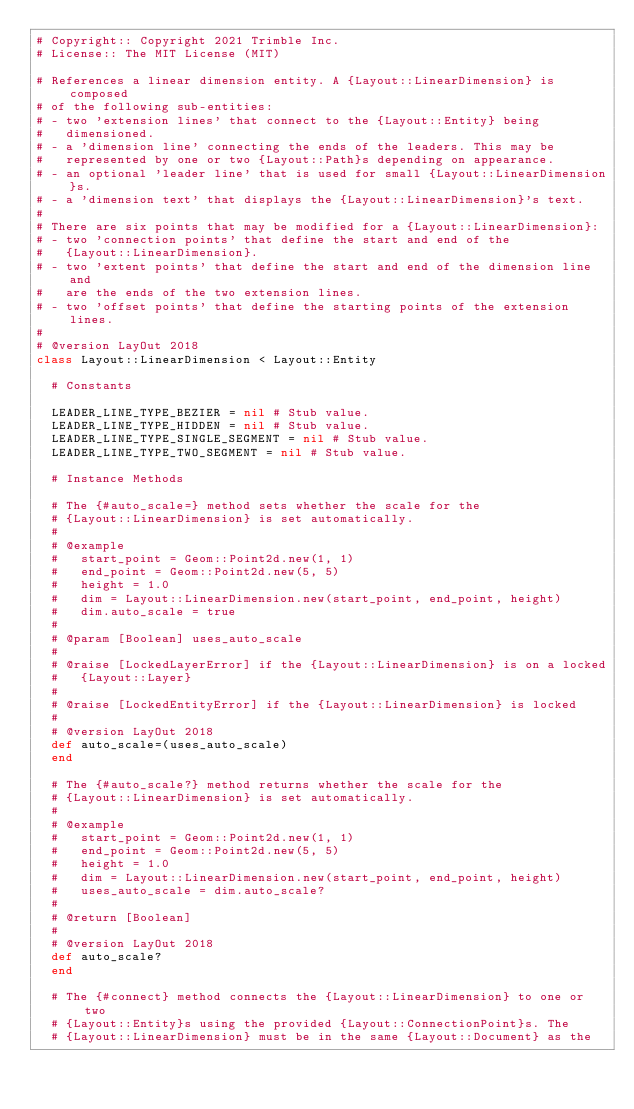<code> <loc_0><loc_0><loc_500><loc_500><_Ruby_># Copyright:: Copyright 2021 Trimble Inc.
# License:: The MIT License (MIT)

# References a linear dimension entity. A {Layout::LinearDimension} is composed
# of the following sub-entities:
# - two 'extension lines' that connect to the {Layout::Entity} being
#   dimensioned.
# - a 'dimension line' connecting the ends of the leaders. This may be
#   represented by one or two {Layout::Path}s depending on appearance.
# - an optional 'leader line' that is used for small {Layout::LinearDimension}s.
# - a 'dimension text' that displays the {Layout::LinearDimension}'s text.
#
# There are six points that may be modified for a {Layout::LinearDimension}:
# - two 'connection points' that define the start and end of the
#   {Layout::LinearDimension}.
# - two 'extent points' that define the start and end of the dimension line and
#   are the ends of the two extension lines.
# - two 'offset points' that define the starting points of the extension lines.
#
# @version LayOut 2018
class Layout::LinearDimension < Layout::Entity

  # Constants

  LEADER_LINE_TYPE_BEZIER = nil # Stub value.
  LEADER_LINE_TYPE_HIDDEN = nil # Stub value.
  LEADER_LINE_TYPE_SINGLE_SEGMENT = nil # Stub value.
  LEADER_LINE_TYPE_TWO_SEGMENT = nil # Stub value.

  # Instance Methods

  # The {#auto_scale=} method sets whether the scale for the
  # {Layout::LinearDimension} is set automatically.
  #
  # @example
  #   start_point = Geom::Point2d.new(1, 1)
  #   end_point = Geom::Point2d.new(5, 5)
  #   height = 1.0
  #   dim = Layout::LinearDimension.new(start_point, end_point, height)
  #   dim.auto_scale = true
  #
  # @param [Boolean] uses_auto_scale
  #
  # @raise [LockedLayerError] if the {Layout::LinearDimension} is on a locked
  #   {Layout::Layer}
  #
  # @raise [LockedEntityError] if the {Layout::LinearDimension} is locked
  #
  # @version LayOut 2018
  def auto_scale=(uses_auto_scale)
  end

  # The {#auto_scale?} method returns whether the scale for the
  # {Layout::LinearDimension} is set automatically.
  #
  # @example
  #   start_point = Geom::Point2d.new(1, 1)
  #   end_point = Geom::Point2d.new(5, 5)
  #   height = 1.0
  #   dim = Layout::LinearDimension.new(start_point, end_point, height)
  #   uses_auto_scale = dim.auto_scale?
  #
  # @return [Boolean]
  #
  # @version LayOut 2018
  def auto_scale?
  end

  # The {#connect} method connects the {Layout::LinearDimension} to one or two
  # {Layout::Entity}s using the provided {Layout::ConnectionPoint}s. The
  # {Layout::LinearDimension} must be in the same {Layout::Document} as the</code> 